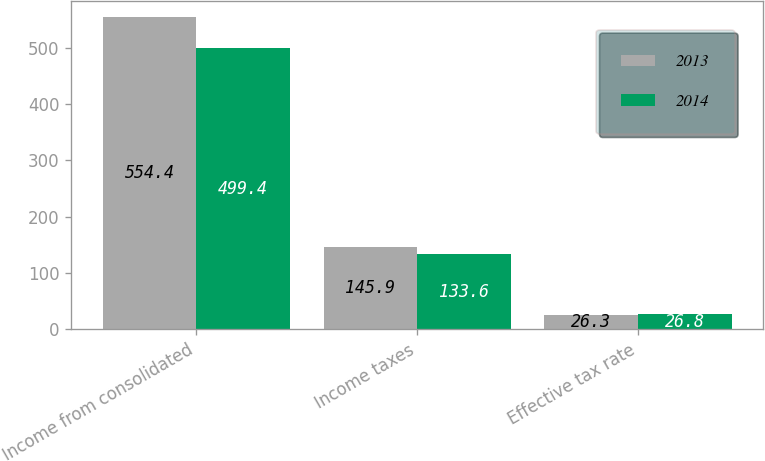Convert chart. <chart><loc_0><loc_0><loc_500><loc_500><stacked_bar_chart><ecel><fcel>Income from consolidated<fcel>Income taxes<fcel>Effective tax rate<nl><fcel>2013<fcel>554.4<fcel>145.9<fcel>26.3<nl><fcel>2014<fcel>499.4<fcel>133.6<fcel>26.8<nl></chart> 